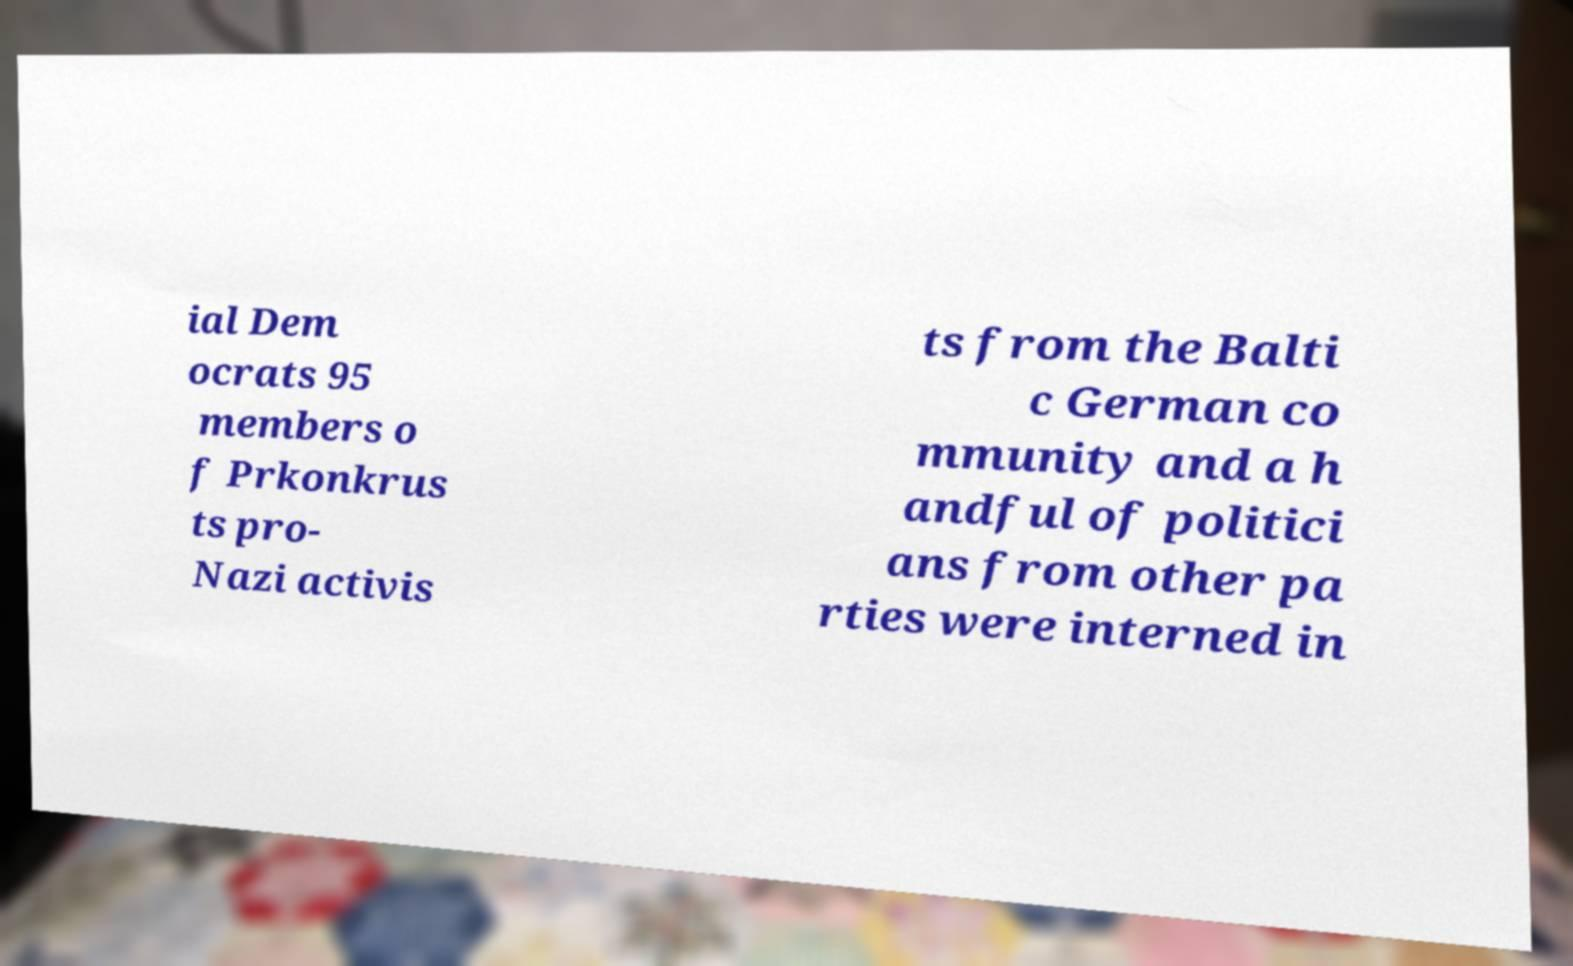Can you accurately transcribe the text from the provided image for me? ial Dem ocrats 95 members o f Prkonkrus ts pro- Nazi activis ts from the Balti c German co mmunity and a h andful of politici ans from other pa rties were interned in 